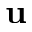Convert formula to latex. <formula><loc_0><loc_0><loc_500><loc_500>u</formula> 